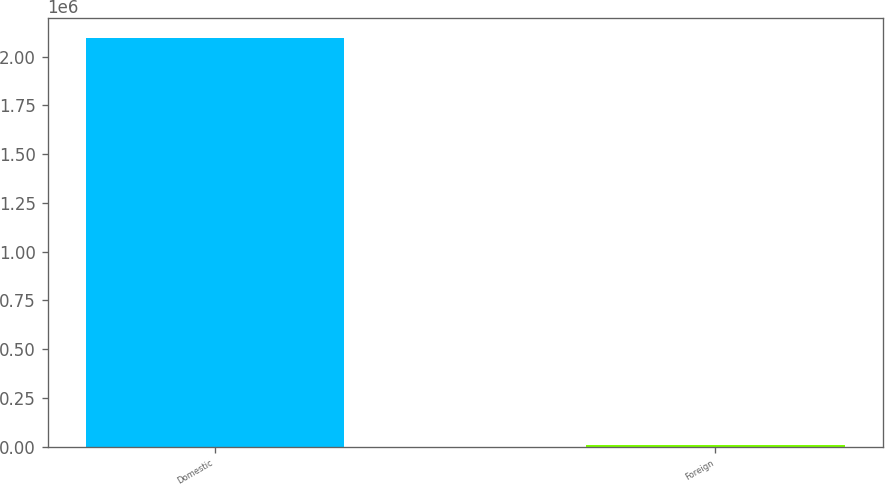Convert chart. <chart><loc_0><loc_0><loc_500><loc_500><bar_chart><fcel>Domestic<fcel>Foreign<nl><fcel>2.09581e+06<fcel>7134<nl></chart> 